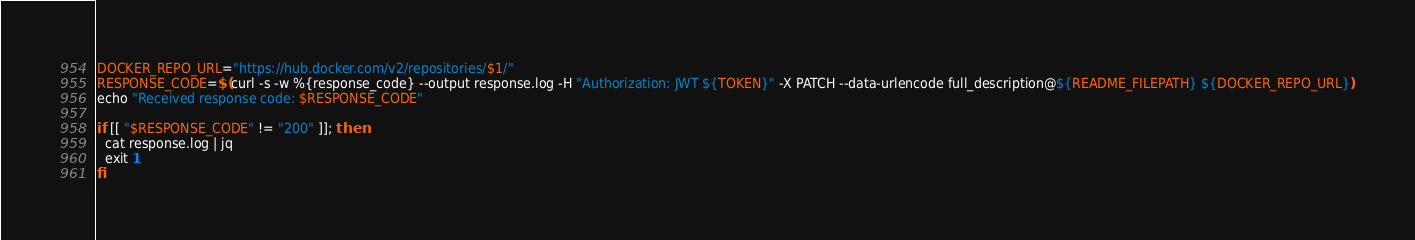<code> <loc_0><loc_0><loc_500><loc_500><_Bash_>DOCKER_REPO_URL="https://hub.docker.com/v2/repositories/$1/"
RESPONSE_CODE=$(curl -s -w %{response_code} --output response.log -H "Authorization: JWT ${TOKEN}" -X PATCH --data-urlencode full_description@${README_FILEPATH} ${DOCKER_REPO_URL})
echo "Received response code: $RESPONSE_CODE"

if [[ "$RESPONSE_CODE" != "200" ]]; then
  cat response.log | jq
  exit 1
fi
</code> 